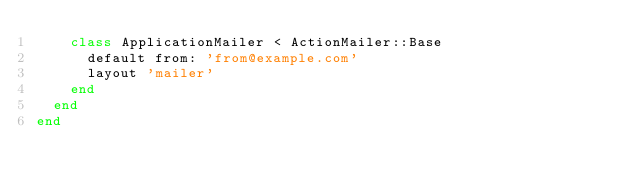<code> <loc_0><loc_0><loc_500><loc_500><_Ruby_>    class ApplicationMailer < ActionMailer::Base
      default from: 'from@example.com'
      layout 'mailer'
    end
  end
end
</code> 